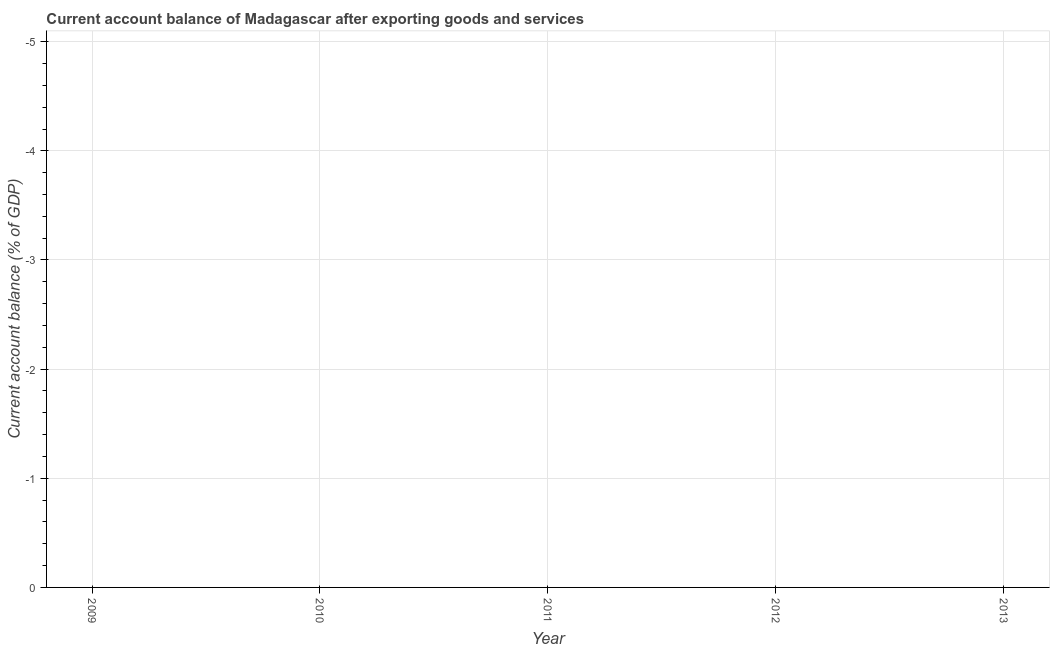What is the current account balance in 2012?
Your answer should be very brief. 0. What is the average current account balance per year?
Your answer should be very brief. 0. What is the median current account balance?
Your answer should be compact. 0. In how many years, is the current account balance greater than -1.2 %?
Make the answer very short. 0. What is the difference between two consecutive major ticks on the Y-axis?
Provide a succinct answer. 1. Does the graph contain grids?
Give a very brief answer. Yes. What is the title of the graph?
Provide a short and direct response. Current account balance of Madagascar after exporting goods and services. What is the label or title of the X-axis?
Provide a short and direct response. Year. What is the label or title of the Y-axis?
Ensure brevity in your answer.  Current account balance (% of GDP). What is the Current account balance (% of GDP) in 2010?
Your response must be concise. 0. What is the Current account balance (% of GDP) in 2011?
Offer a terse response. 0. What is the Current account balance (% of GDP) in 2012?
Your answer should be compact. 0. 